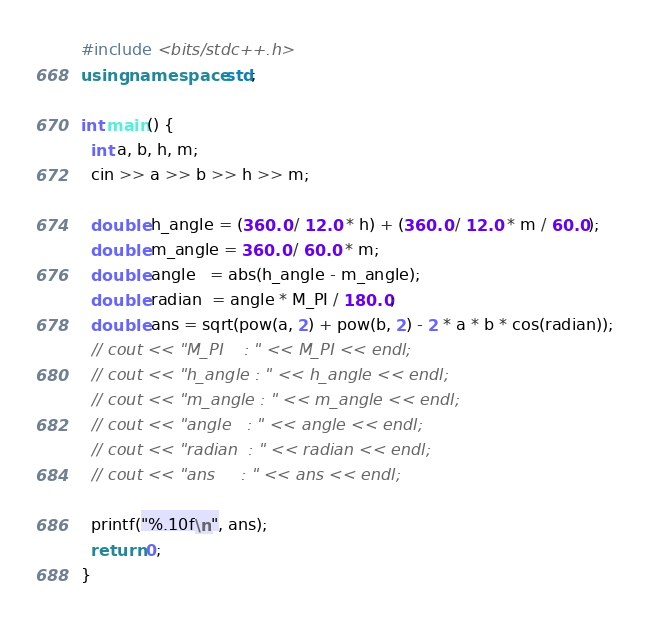Convert code to text. <code><loc_0><loc_0><loc_500><loc_500><_C++_>#include <bits/stdc++.h>
using namespace std;

int main() {
  int a, b, h, m;
  cin >> a >> b >> h >> m;

  double h_angle = (360.0 / 12.0 * h) + (360.0 / 12.0 * m / 60.0);
  double m_angle = 360.0 / 60.0 * m;
  double angle   = abs(h_angle - m_angle);
  double radian  = angle * M_PI / 180.0;
  double ans = sqrt(pow(a, 2) + pow(b, 2) - 2 * a * b * cos(radian));
  // cout << "M_PI    : " << M_PI << endl;
  // cout << "h_angle : " << h_angle << endl;
  // cout << "m_angle : " << m_angle << endl;
  // cout << "angle   : " << angle << endl;
  // cout << "radian  : " << radian << endl;
  // cout << "ans     : " << ans << endl;

  printf("%.10f\n", ans);
  return 0;
}
</code> 